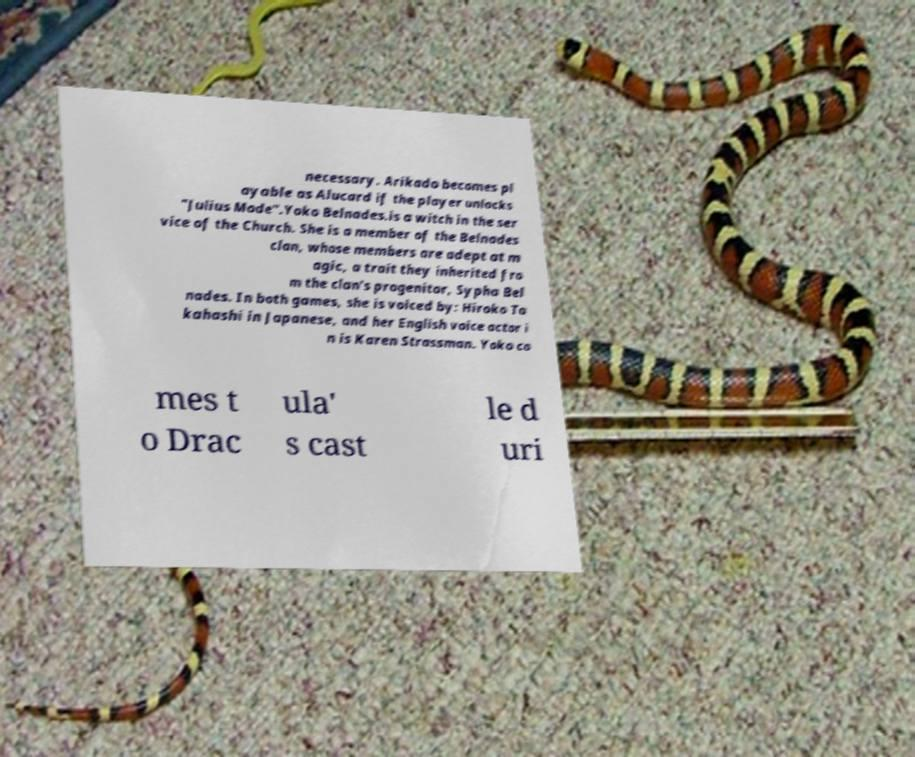What messages or text are displayed in this image? I need them in a readable, typed format. necessary. Arikado becomes pl ayable as Alucard if the player unlocks "Julius Mode".Yoko Belnades.is a witch in the ser vice of the Church. She is a member of the Belnades clan, whose members are adept at m agic, a trait they inherited fro m the clan's progenitor, Sypha Bel nades. In both games, she is voiced by: Hiroko Ta kahashi in Japanese, and her English voice actor i n is Karen Strassman. Yoko co mes t o Drac ula' s cast le d uri 